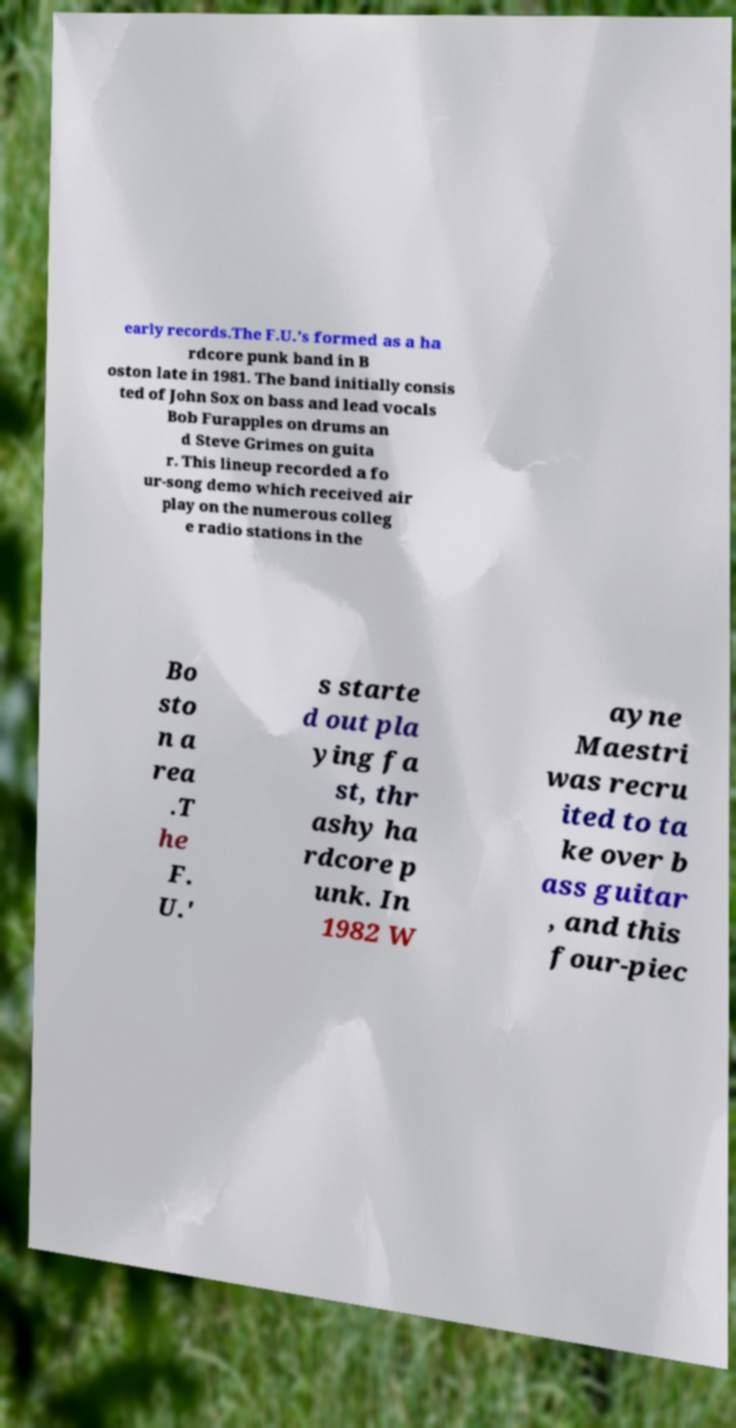For documentation purposes, I need the text within this image transcribed. Could you provide that? early records.The F.U.’s formed as a ha rdcore punk band in B oston late in 1981. The band initially consis ted of John Sox on bass and lead vocals Bob Furapples on drums an d Steve Grimes on guita r. This lineup recorded a fo ur-song demo which received air play on the numerous colleg e radio stations in the Bo sto n a rea .T he F. U.' s starte d out pla ying fa st, thr ashy ha rdcore p unk. In 1982 W ayne Maestri was recru ited to ta ke over b ass guitar , and this four-piec 